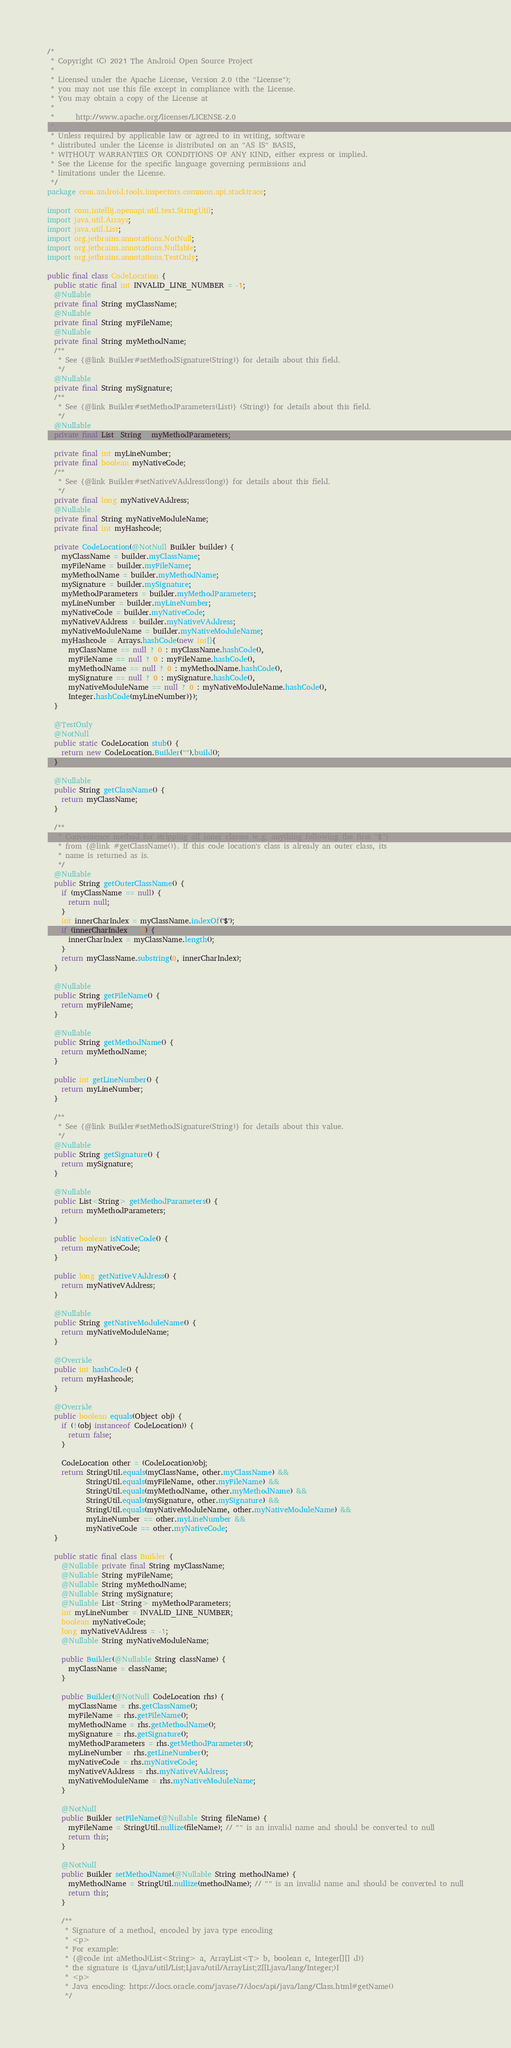Convert code to text. <code><loc_0><loc_0><loc_500><loc_500><_Java_>/*
 * Copyright (C) 2021 The Android Open Source Project
 *
 * Licensed under the Apache License, Version 2.0 (the "License");
 * you may not use this file except in compliance with the License.
 * You may obtain a copy of the License at
 *
 *      http://www.apache.org/licenses/LICENSE-2.0
 *
 * Unless required by applicable law or agreed to in writing, software
 * distributed under the License is distributed on an "AS IS" BASIS,
 * WITHOUT WARRANTIES OR CONDITIONS OF ANY KIND, either express or implied.
 * See the License for the specific language governing permissions and
 * limitations under the License.
 */
package com.android.tools.inspectors.common.api.stacktrace;

import com.intellij.openapi.util.text.StringUtil;
import java.util.Arrays;
import java.util.List;
import org.jetbrains.annotations.NotNull;
import org.jetbrains.annotations.Nullable;
import org.jetbrains.annotations.TestOnly;

public final class CodeLocation {
  public static final int INVALID_LINE_NUMBER = -1;
  @Nullable
  private final String myClassName;
  @Nullable
  private final String myFileName;
  @Nullable
  private final String myMethodName;
  /**
   * See {@link Builder#setMethodSignature(String)} for details about this field.
   */
  @Nullable
  private final String mySignature;
  /**
   * See {@link Builder#setMethodParameters(List)} (String)} for details about this field.
   */
  @Nullable
  private final List<String> myMethodParameters;

  private final int myLineNumber;
  private final boolean myNativeCode;
  /**
   * See {@link Builder#setNativeVAddress(long)} for details about this field.
   */
  private final long myNativeVAddress;
  @Nullable
  private final String myNativeModuleName;
  private final int myHashcode;

  private CodeLocation(@NotNull Builder builder) {
    myClassName = builder.myClassName;
    myFileName = builder.myFileName;
    myMethodName = builder.myMethodName;
    mySignature = builder.mySignature;
    myMethodParameters = builder.myMethodParameters;
    myLineNumber = builder.myLineNumber;
    myNativeCode = builder.myNativeCode;
    myNativeVAddress = builder.myNativeVAddress;
    myNativeModuleName = builder.myNativeModuleName;
    myHashcode = Arrays.hashCode(new int[]{
      myClassName == null ? 0 : myClassName.hashCode(),
      myFileName == null ? 0 : myFileName.hashCode(),
      myMethodName == null ? 0 : myMethodName.hashCode(),
      mySignature == null ? 0 : mySignature.hashCode(),
      myNativeModuleName == null ? 0 : myNativeModuleName.hashCode(),
      Integer.hashCode(myLineNumber)});
  }

  @TestOnly
  @NotNull
  public static CodeLocation stub() {
    return new CodeLocation.Builder("").build();
  }

  @Nullable
  public String getClassName() {
    return myClassName;
  }

  /**
   * Convenience method for stripping all inner classes (e.g. anything following the first "$")
   * from {@link #getClassName()}. If this code location's class is already an outer class, its
   * name is returned as is.
   */
  @Nullable
  public String getOuterClassName() {
    if (myClassName == null) {
      return null;
    }
    int innerCharIndex = myClassName.indexOf('$');
    if (innerCharIndex < 0) {
      innerCharIndex = myClassName.length();
    }
    return myClassName.substring(0, innerCharIndex);
  }

  @Nullable
  public String getFileName() {
    return myFileName;
  }

  @Nullable
  public String getMethodName() {
    return myMethodName;
  }

  public int getLineNumber() {
    return myLineNumber;
  }

  /**
   * See {@link Builder#setMethodSignature(String)} for details about this value.
   */
  @Nullable
  public String getSignature() {
    return mySignature;
  }

  @Nullable
  public List<String> getMethodParameters() {
    return myMethodParameters;
  }

  public boolean isNativeCode() {
    return myNativeCode;
  }

  public long getNativeVAddress() {
    return myNativeVAddress;
  }

  @Nullable
  public String getNativeModuleName() {
    return myNativeModuleName;
  }

  @Override
  public int hashCode() {
    return myHashcode;
  }

  @Override
  public boolean equals(Object obj) {
    if (!(obj instanceof CodeLocation)) {
      return false;
    }

    CodeLocation other = (CodeLocation)obj;
    return StringUtil.equals(myClassName, other.myClassName) &&
           StringUtil.equals(myFileName, other.myFileName) &&
           StringUtil.equals(myMethodName, other.myMethodName) &&
           StringUtil.equals(mySignature, other.mySignature) &&
           StringUtil.equals(myNativeModuleName, other.myNativeModuleName) &&
           myLineNumber == other.myLineNumber &&
           myNativeCode == other.myNativeCode;
  }

  public static final class Builder {
    @Nullable private final String myClassName;
    @Nullable String myFileName;
    @Nullable String myMethodName;
    @Nullable String mySignature;
    @Nullable List<String> myMethodParameters;
    int myLineNumber = INVALID_LINE_NUMBER;
    boolean myNativeCode;
    long myNativeVAddress = -1;
    @Nullable String myNativeModuleName;

    public Builder(@Nullable String className) {
      myClassName = className;
    }

    public Builder(@NotNull CodeLocation rhs) {
      myClassName = rhs.getClassName();
      myFileName = rhs.getFileName();
      myMethodName = rhs.getMethodName();
      mySignature = rhs.getSignature();
      myMethodParameters = rhs.getMethodParameters();
      myLineNumber = rhs.getLineNumber();
      myNativeCode = rhs.myNativeCode;
      myNativeVAddress = rhs.myNativeVAddress;
      myNativeModuleName = rhs.myNativeModuleName;
    }

    @NotNull
    public Builder setFileName(@Nullable String fileName) {
      myFileName = StringUtil.nullize(fileName); // "" is an invalid name and should be converted to null
      return this;
    }

    @NotNull
    public Builder setMethodName(@Nullable String methodName) {
      myMethodName = StringUtil.nullize(methodName); // "" is an invalid name and should be converted to null
      return this;
    }

    /**
     * Signature of a method, encoded by java type encoding
     * <p>
     * For example:
     * {@code int aMethod(List<String> a, ArrayList<T> b, boolean c, Integer[][] d)}
     * the signature is (Ljava/util/List;Ljava/util/ArrayList;Z[[Ljava/lang/Integer;)I
     * <p>
     * Java encoding: https://docs.oracle.com/javase/7/docs/api/java/lang/Class.html#getName()
     */</code> 